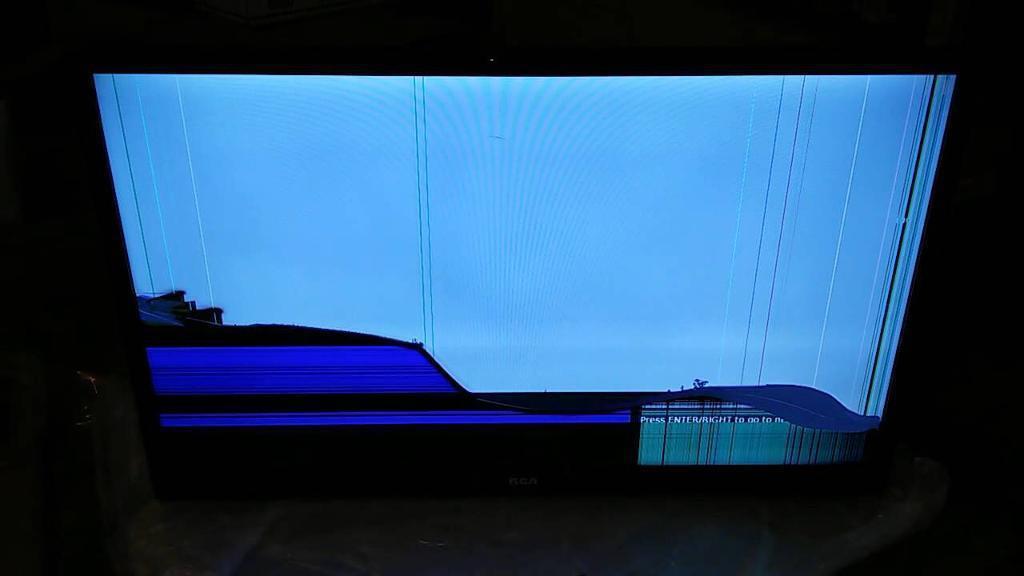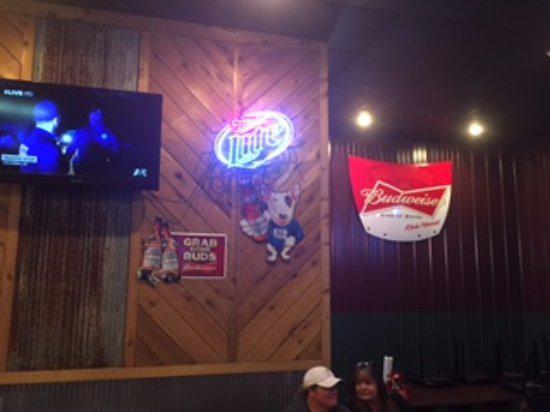The first image is the image on the left, the second image is the image on the right. Considering the images on both sides, is "Chairs are available for people to view the screens in at least one of the images." valid? Answer yes or no. No. The first image is the image on the left, the second image is the image on the right. Given the left and right images, does the statement "One image depicts one or more televisions in a sports bar." hold true? Answer yes or no. Yes. 